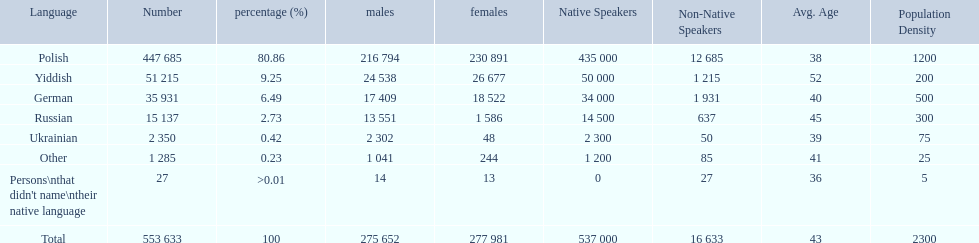What was the highest percentage of one language spoken by the plock governorate? 80.86. What language was spoken by 80.86 percent of the people? Polish. 